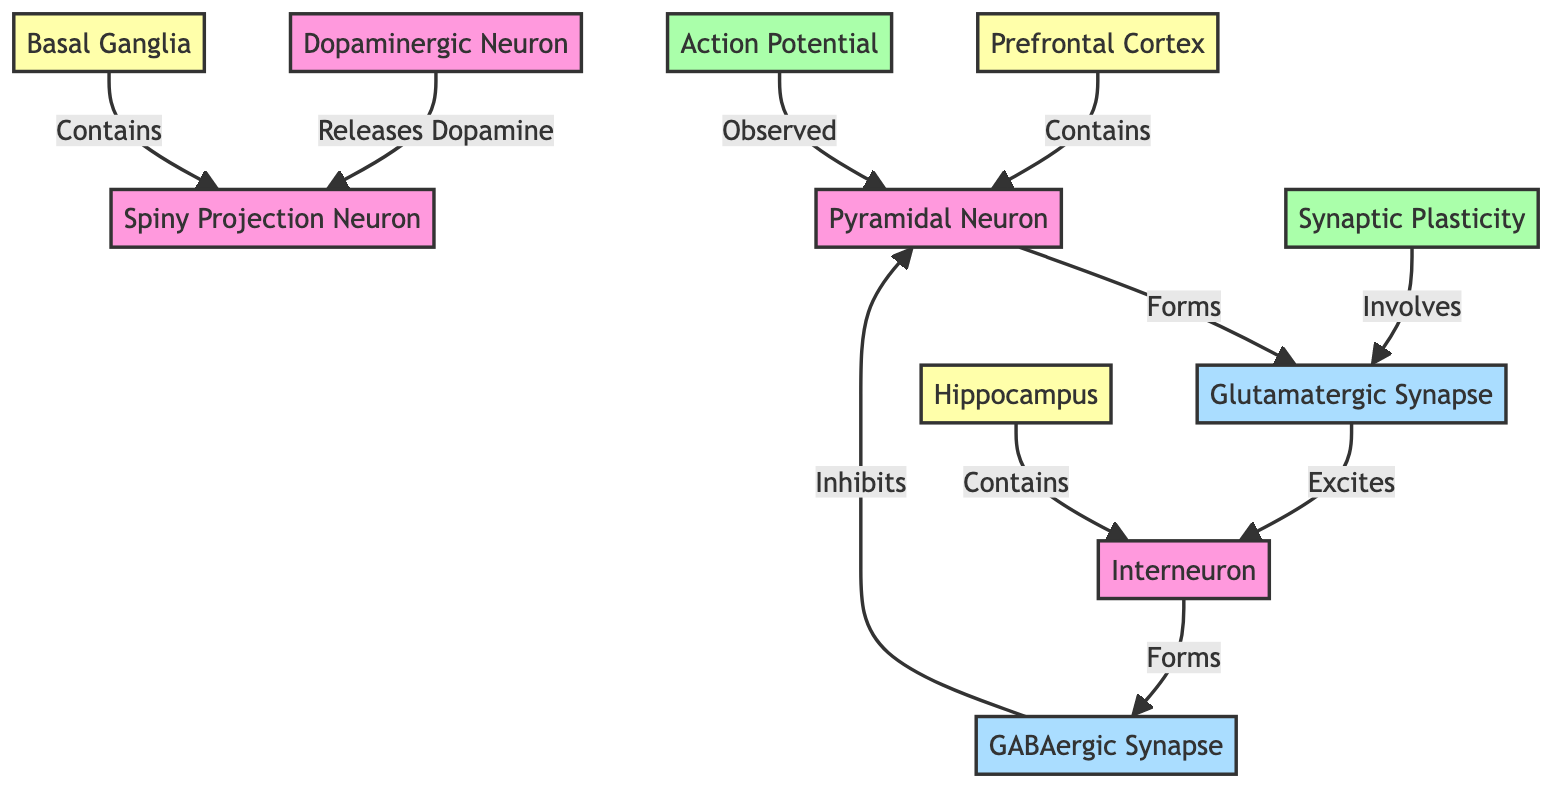What neuron forms a glutamatergic synapse? The diagram indicates that Neuron A, a Pyramidal Neuron, forms the Glutamatergic Synapse. This can be seen through the directed arrow from Neuron A to Synapse 1, which labels it as "Forms".
Answer: Pyramidal Neuron Which type of activity is observed in Neuron A? According to the diagram, Neuron A exhibits "Action Potential", as indicated by the arrow from Neural Activity 1 labeling it as "Observed".
Answer: Action Potential What type of synapse does Neuron B form? The diagram shows that Neuron B forms a GABAergic Synapse. This relationship is illustrated with an arrow indicating that Neuron B "Forms" Synapse 2, which is labeled as GABAergic.
Answer: GABAergic Synapse Which brain region contains Neuron D? The diagram specifies that Neuron D is contained within the Basal Ganglia, as indicated by the directional arrow from Brain Region 3 to Neuron D, labeled "Contains".
Answer: Basal Ganglia How many types of neurons are represented in the diagram? The diagram shows four different neurons: Neuron A (Pyramidal Neuron), Neuron B (Interneuron), Neuron C (Dopaminergic Neuron), and Neuron D (Spiny Projection Neuron). Counting these nodes confirms a total of four neurons.
Answer: 4 What is the relationship between Neuron C and Neuron D? The diagram establishes that Neuron C "Releases Dopamine" to Neuron D, indicating a direct influence or interaction between the two neurons. This can be traced through the arrow connecting Neuron C to Neuron D.
Answer: Releases Dopamine Which brain region contains Neuron A? The diagram indicates that Neuron A is located in the Prefrontal Cortex, shown by the arrow from Brain Region 1 to Neuron A, labeled as "Contains".
Answer: Prefrontal Cortex What kind of synaptic plasticity involves Synapse 1? The diagram states that "Synaptic Plasticity" involves Synapse 1, indicated by an arrow from Neural Activity 2 to Synapse 1, denoting this relationship.
Answer: Synaptic Plasticity 